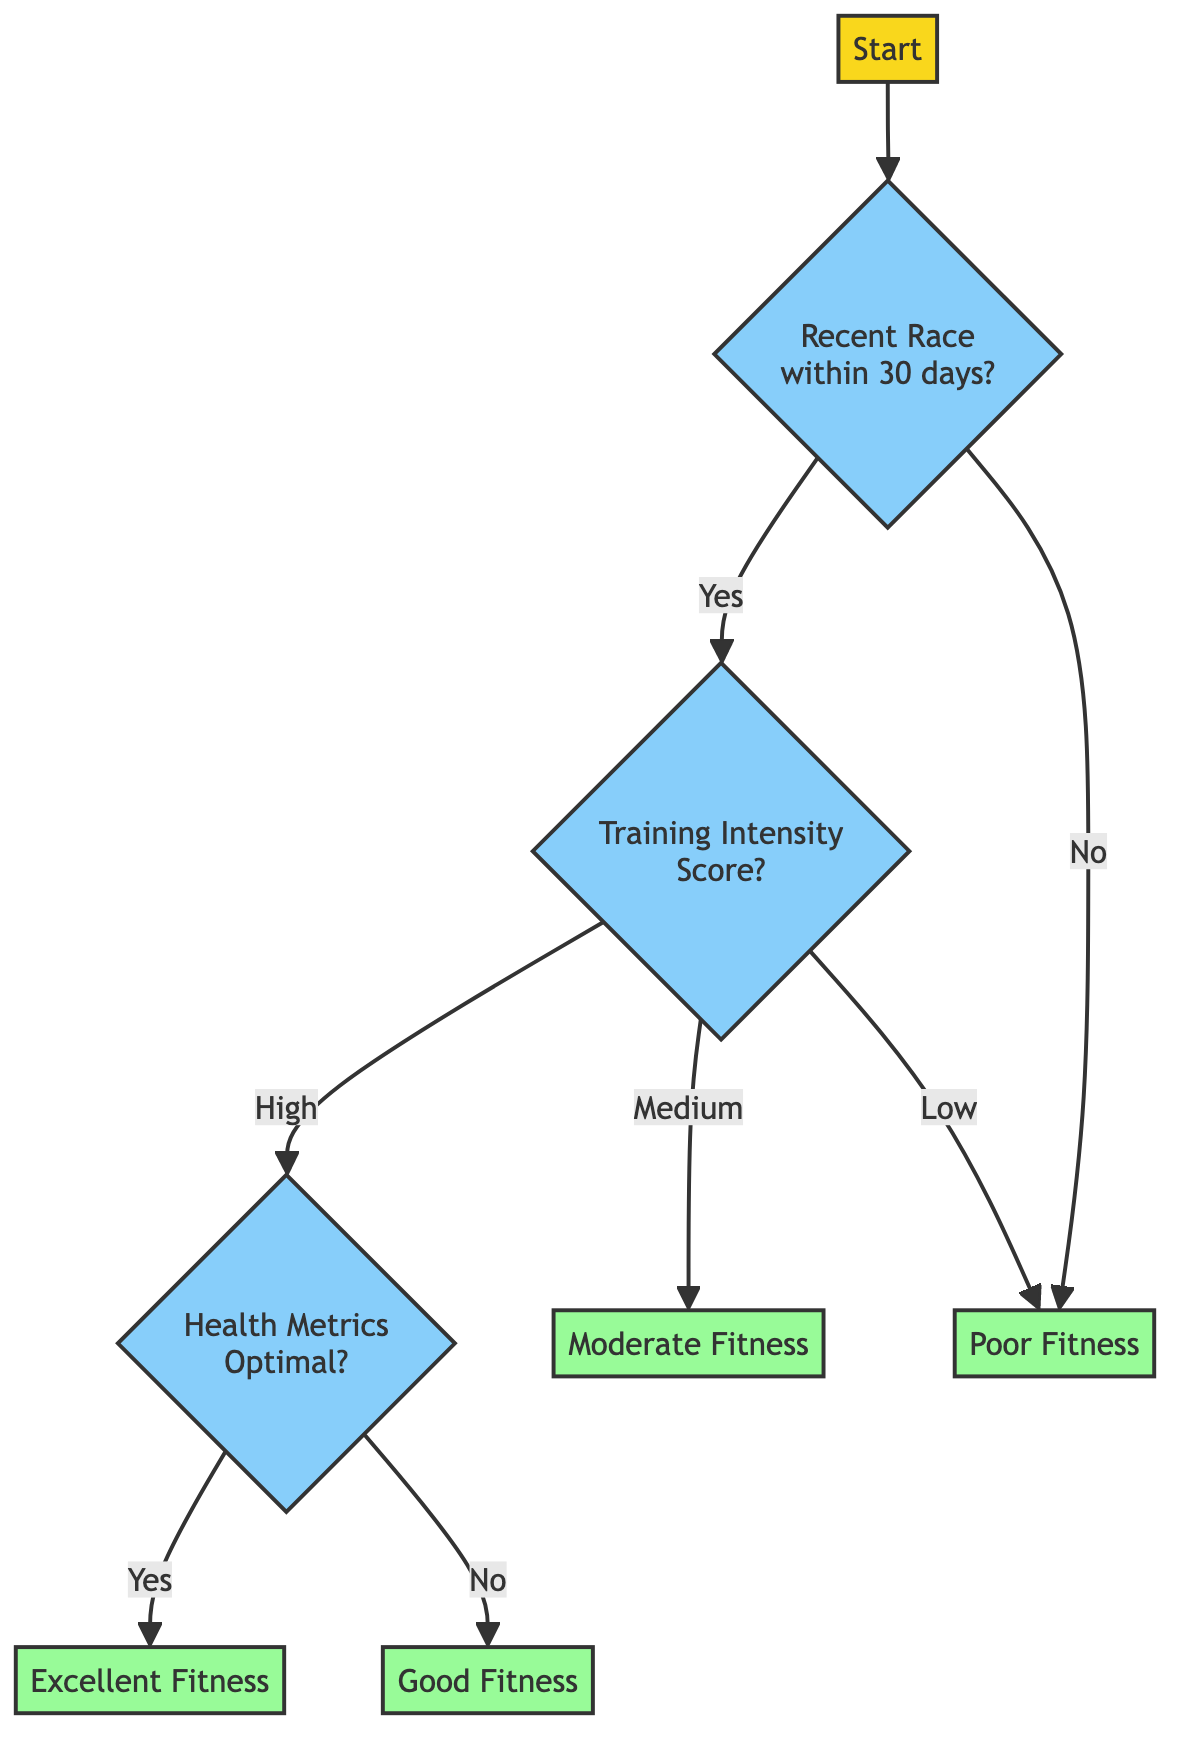What is the first decision point in the diagram? The first decision point is the node that asks whether the horse has participated in a race within the last 30 days. This node is connected to the "Start" node and is identified as node 2 in the diagram.
Answer: Has the horse participated in a race within the last 30 days? How many outcome nodes are present in the diagram? The diagram includes four outcome nodes, which are labeled as Fitness Level: Excellent, Fitness Level: Good, Fitness Level: Moderate, and Fitness Level: Poor. These nodes are the endpoints of the flowchart.
Answer: Four What happens if the horse has not participated in a race within the last 30 days? If the horse has not participated in a race within the last 30 days, the flowchart leads directly to the outcome node indicating Poor Fitness, bypassing any further evaluation of training intensity or health metrics.
Answer: Poor Fitness If the training intensity score is high and health metrics are optimal, what is the resulting fitness level? Starting with a high training intensity score, the flow would then require checking health metrics. Since the health metrics are optimal as well, the diagram indicates that the resulting fitness level is Excellent.
Answer: Excellent Fitness What is the outcome if the horse has medium training intensity and health metrics are not optimal? In the case of a medium training intensity score, the flow chart leads to the outcome node indicating Moderate Fitness. The health metric check only applies if the training intensity is high. Hence, the health metrics being not optimal does not affect this path.
Answer: Moderate Fitness What is the relationship between training intensity and health metrics in determining fitness levels? The relationship is sequential and conditional: training intensity is evaluated first, with outcomes of high, medium, or low leading to different paths. If it is high, only then do we evaluate the health metrics, resulting in either Excellent or Good fitness levels based on whether the health metrics are optimal or not.
Answer: Sequential and conditional 